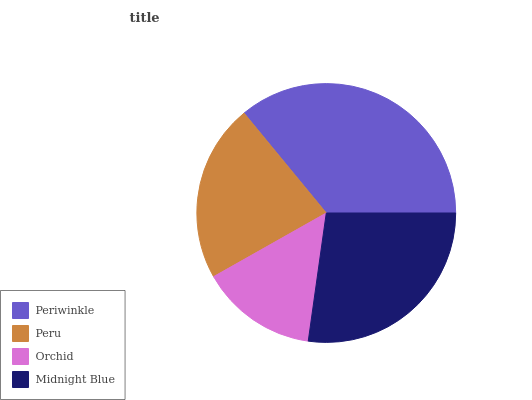Is Orchid the minimum?
Answer yes or no. Yes. Is Periwinkle the maximum?
Answer yes or no. Yes. Is Peru the minimum?
Answer yes or no. No. Is Peru the maximum?
Answer yes or no. No. Is Periwinkle greater than Peru?
Answer yes or no. Yes. Is Peru less than Periwinkle?
Answer yes or no. Yes. Is Peru greater than Periwinkle?
Answer yes or no. No. Is Periwinkle less than Peru?
Answer yes or no. No. Is Midnight Blue the high median?
Answer yes or no. Yes. Is Peru the low median?
Answer yes or no. Yes. Is Periwinkle the high median?
Answer yes or no. No. Is Midnight Blue the low median?
Answer yes or no. No. 